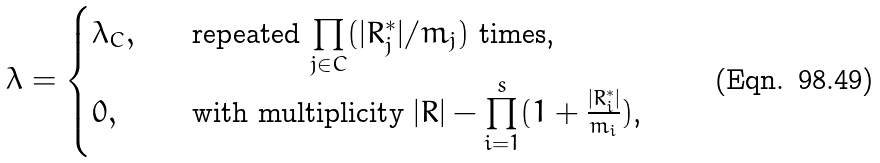<formula> <loc_0><loc_0><loc_500><loc_500>\lambda = \begin{cases} \lambda _ { C } , & \quad \text {repeated $\prod\limits_{j \in C} (|R_{j}^{*}|/m_{j})$ times,} \\ 0 , & \quad \text {with multiplicity $|R|- \prod\limits_{i=1}^{s} (1+ \frac{|R_{i}^{*}|}{m_{i}})$,} \end{cases}</formula> 